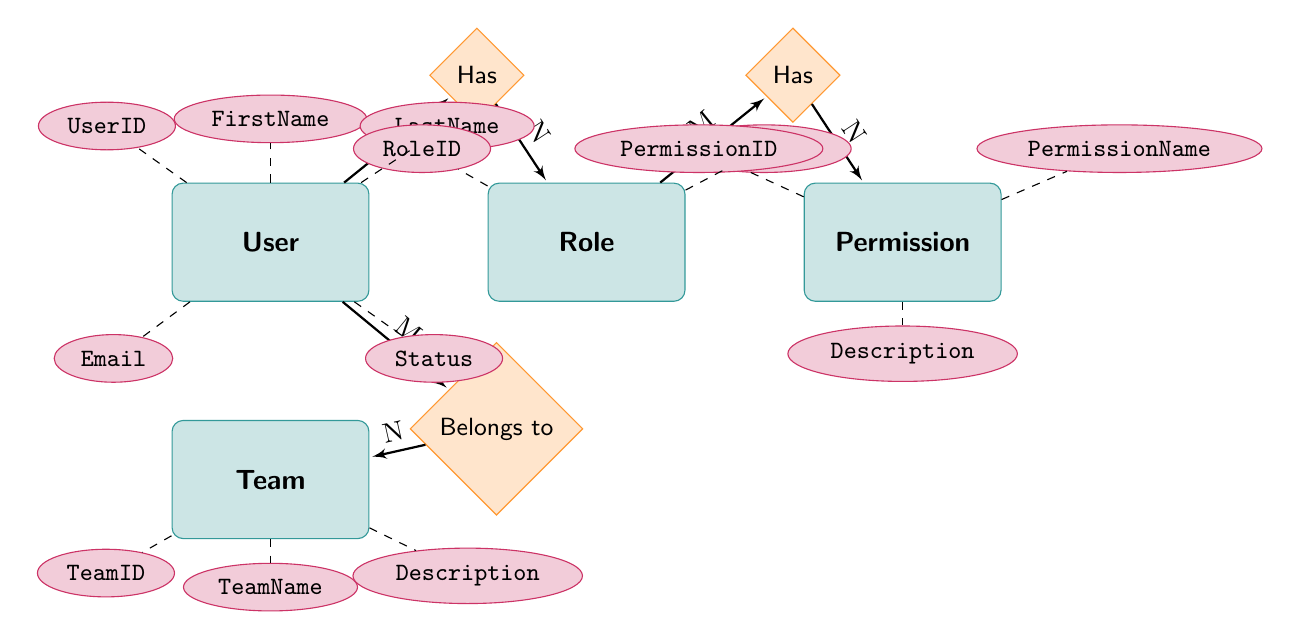What's the total number of entities in the diagram? The diagram shows a total of five entities, which are User, Role, Permission, Team, and User_Team. Each of these represents a key aspect of the user management system.
Answer: 5 What attribute is associated with the User entity? The User entity has several attributes, including UserID, FirstName, LastName, Email, Role, and Status. The question specifically asks for any attribute, so we can choose one, such as UserID.
Answer: UserID What is the type of relationship between the User and Role entities? In the diagram, the relationship between User and Role is described as "many-to-one," meaning each user is associated with one role, but a role can apply to many users.
Answer: many-to-one How many permissions can a single role have? The diagram shows that the relationship between Role and Permission is "many-to-many," indicating that a single role can have multiple permissions assigned to it.
Answer: many Which entity can have multiple teams associated with it? The relationship between User and Team is many-to-many, meaning that users can belong to multiple teams. Therefore, the User entity can have multiple teams associated with it.
Answer: User How many attributes does the Role entity have? The Role entity has three defined attributes: RoleID, RoleName, and Permissions. By counting these, we find that the Role entity contains three attributes total.
Answer: 3 Which relationship connects the User entity to the Team entity? The relationship that connects the User entity to the Team entity is called "Belongs to," indicating that users belong to teams and teams can consist of multiple users as well.
Answer: Belongs to What is the primary key for the Permission entity? The primary key for the Permission entity, as indicated by the attributes listed, is PermissionID. This serves as the unique identifier for each permission within the system.
Answer: PermissionID How are users linked to teams in the diagram? Users are linked to teams through a join table or associative entity called User_Team, which facilitates the many-to-many relationship and contains both UserID and TeamID to connect them.
Answer: User_Team 